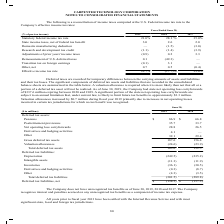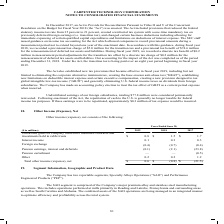According to Carpenter Technology's financial document, What was the Postretirement provisions in 2019? According to the financial document, 35.7 (in millions). The relevant text states: "Pensions $ 86.9 $ 66.8 Postretirement provisions 35.7 33.7 Net operating loss carryforwards 28.8 26.5 Derivatives and hedging activities 4.1 — Other 32.1..." Also, What was the  Net operating loss carryforwards in 2018? According to the financial document, 26.5 (in millions). The relevant text states: "s 35.7 33.7 Net operating loss carryforwards 28.8 26.5 Derivatives and hedging activities 4.1 — Other 32.1 29.4 Gross deferred tax assets 187.6 156.4 Valu..." Also, In which years was the amount of deferred tax liabilities, net calculated? The document shows two values: 2019 and 2018. From the document: "($ in millions) 2019 2018 Deferred tax assets: Pensions $ 86.9 $ 66.8 Postretirement provisions 35.7 33.7 Net operating ($ in millions) 2019 2018 Defe..." Additionally, In which year was the amount of Postretirement provisions larger? According to the financial document, 2019. The relevant text states: "($ in millions) 2019 2018 Deferred tax assets: Pensions $ 86.9 $ 66.8 Postretirement provisions 35.7 33.7 Net operating..." Also, can you calculate: What was the change in Pensions in 2019 from 2018? Based on the calculation: 86.9-66.8, the result is 20.1 (in millions). This is based on the information: "llions) 2019 2018 Deferred tax assets: Pensions $ 86.9 $ 66.8 Postretirement provisions 35.7 33.7 Net operating loss carryforwards 28.8 26.5 Derivatives a 2019 2018 Deferred tax assets: Pensions $ 86...." The key data points involved are: 66.8, 86.9. Also, can you calculate: What was the percentage change in Pensions in 2019 from 2018? To answer this question, I need to perform calculations using the financial data. The calculation is: (86.9-66.8)/66.8, which equals 30.09 (percentage). This is based on the information: "llions) 2019 2018 Deferred tax assets: Pensions $ 86.9 $ 66.8 Postretirement provisions 35.7 33.7 Net operating loss carryforwards 28.8 26.5 Derivatives a 2019 2018 Deferred tax assets: Pensions $ 86...." The key data points involved are: 66.8, 86.9. 